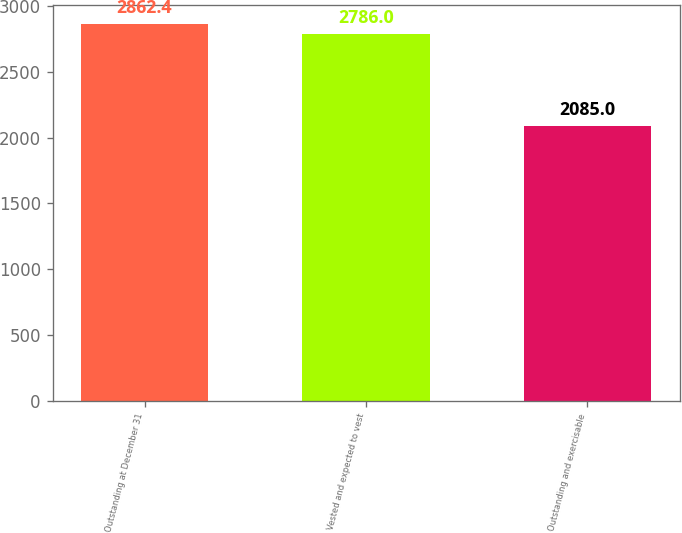Convert chart to OTSL. <chart><loc_0><loc_0><loc_500><loc_500><bar_chart><fcel>Outstanding at December 31<fcel>Vested and expected to vest<fcel>Outstanding and exercisable<nl><fcel>2862.4<fcel>2786<fcel>2085<nl></chart> 